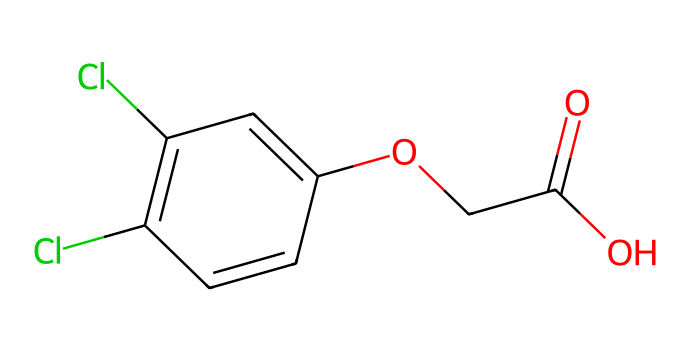What is the molecular weight of 2,4-Dichlorophenoxyacetic acid? The molecular weight can be calculated by adding the atomic weights of all the atoms in the molecule: Carbon (C) 2x1 + Oxygen (O) 5x16 + Chlorine (Cl) 2x35.5 + Hydrogen (H) 4x1. This gives a total molecular weight of approximately 221.01 g/mol.
Answer: 221.01 g/mol How many chlorine atoms are present in 2,4-Dichlorophenoxyacetic acid? The SMILES representation shows two "Cl" symbols, indicating the presence of two chlorine atoms in the chemical structure.
Answer: 2 What functional group is present in 2,4-Dichlorophenoxyacetic acid? The chemical structure features a carboxylic acid group (-COOH) indicated by the "C(=O)O" part of the SMILES string. This is a defining feature of the herbicide's function.
Answer: carboxylic acid What is the purpose of 2,4-Dichlorophenoxyacetic acid in agriculture? This herbicide is primarily used for the control of broadleaf weeds, making use of its chemical properties that selectively target these types of plants without affecting grass species.
Answer: weed control What type of chemical is 2,4-Dichlorophenoxyacetic acid classified as? Given its structure and function, this compound is classified as a selective herbicide, specifically part of the class of phenoxy herbicides, which affect plant growth patterns.
Answer: selective herbicide How many total carbon atoms are in 2,4-Dichlorophenoxyacetic acid? By interpreting the SMILES string, we can observe that there are 10 carbon atoms in total: two in the carboxylic acid part and eight in the benzene ring and ether linkage.
Answer: 10 What is the significance of the hydroxyl group in the structure of 2,4-Dichlorophenoxyacetic acid? The hydroxyl group (-OH), shown as "O" bound to a carbon in the benzene ring, contributes to the herbicide's solubility and its interaction with target plants, influencing its effectiveness.
Answer: herbicide effectiveness 